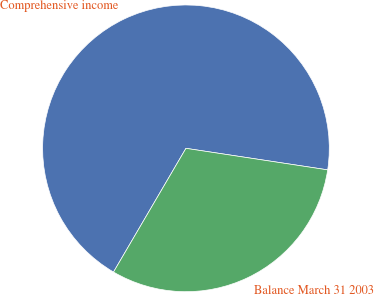Convert chart. <chart><loc_0><loc_0><loc_500><loc_500><pie_chart><fcel>Comprehensive income<fcel>Balance March 31 2003<nl><fcel>68.97%<fcel>31.03%<nl></chart> 